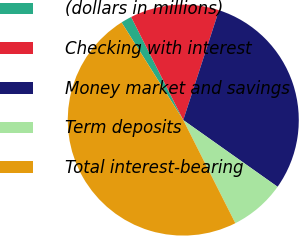Convert chart. <chart><loc_0><loc_0><loc_500><loc_500><pie_chart><fcel>(dollars in millions)<fcel>Checking with interest<fcel>Money market and savings<fcel>Term deposits<fcel>Total interest-bearing<nl><fcel>1.52%<fcel>12.46%<fcel>29.79%<fcel>7.76%<fcel>48.47%<nl></chart> 